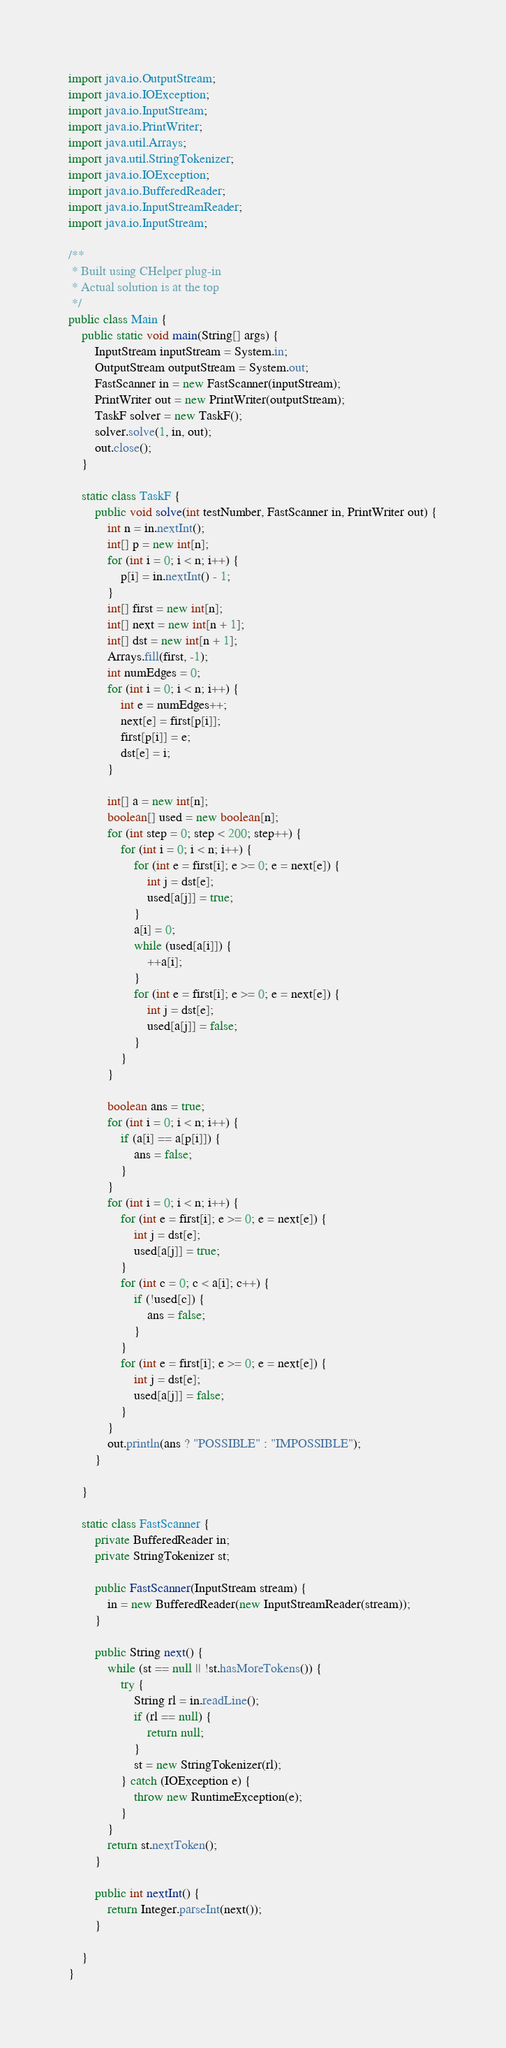<code> <loc_0><loc_0><loc_500><loc_500><_Java_>import java.io.OutputStream;
import java.io.IOException;
import java.io.InputStream;
import java.io.PrintWriter;
import java.util.Arrays;
import java.util.StringTokenizer;
import java.io.IOException;
import java.io.BufferedReader;
import java.io.InputStreamReader;
import java.io.InputStream;

/**
 * Built using CHelper plug-in
 * Actual solution is at the top
 */
public class Main {
	public static void main(String[] args) {
		InputStream inputStream = System.in;
		OutputStream outputStream = System.out;
		FastScanner in = new FastScanner(inputStream);
		PrintWriter out = new PrintWriter(outputStream);
		TaskF solver = new TaskF();
		solver.solve(1, in, out);
		out.close();
	}

	static class TaskF {
		public void solve(int testNumber, FastScanner in, PrintWriter out) {
			int n = in.nextInt();
			int[] p = new int[n];
			for (int i = 0; i < n; i++) {
				p[i] = in.nextInt() - 1;
			}
			int[] first = new int[n];
			int[] next = new int[n + 1];
			int[] dst = new int[n + 1];
			Arrays.fill(first, -1);
			int numEdges = 0;
			for (int i = 0; i < n; i++) {
				int e = numEdges++;
				next[e] = first[p[i]];
				first[p[i]] = e;
				dst[e] = i;
			}

			int[] a = new int[n];
			boolean[] used = new boolean[n];
			for (int step = 0; step < 200; step++) {
				for (int i = 0; i < n; i++) {
					for (int e = first[i]; e >= 0; e = next[e]) {
						int j = dst[e];
						used[a[j]] = true;
					}
					a[i] = 0;
					while (used[a[i]]) {
						++a[i];
					}
					for (int e = first[i]; e >= 0; e = next[e]) {
						int j = dst[e];
						used[a[j]] = false;
					}
				}
			}

			boolean ans = true;
			for (int i = 0; i < n; i++) {
				if (a[i] == a[p[i]]) {
					ans = false;
				}
			}
			for (int i = 0; i < n; i++) {
				for (int e = first[i]; e >= 0; e = next[e]) {
					int j = dst[e];
					used[a[j]] = true;
				}
				for (int c = 0; c < a[i]; c++) {
					if (!used[c]) {
						ans = false;
					}
				}
				for (int e = first[i]; e >= 0; e = next[e]) {
					int j = dst[e];
					used[a[j]] = false;
				}
			}
			out.println(ans ? "POSSIBLE" : "IMPOSSIBLE");
		}

	}

	static class FastScanner {
		private BufferedReader in;
		private StringTokenizer st;

		public FastScanner(InputStream stream) {
			in = new BufferedReader(new InputStreamReader(stream));
		}

		public String next() {
			while (st == null || !st.hasMoreTokens()) {
				try {
					String rl = in.readLine();
					if (rl == null) {
						return null;
					}
					st = new StringTokenizer(rl);
				} catch (IOException e) {
					throw new RuntimeException(e);
				}
			}
			return st.nextToken();
		}

		public int nextInt() {
			return Integer.parseInt(next());
		}

	}
}

</code> 